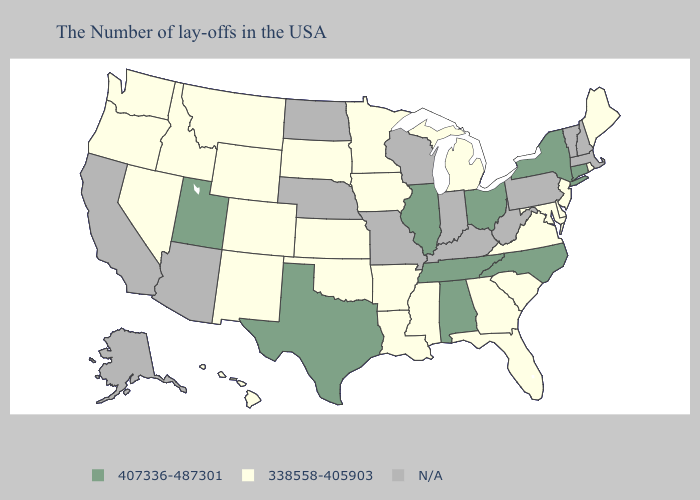What is the lowest value in the USA?
Be succinct. 338558-405903. Name the states that have a value in the range 407336-487301?
Keep it brief. Connecticut, New York, North Carolina, Ohio, Alabama, Tennessee, Illinois, Texas, Utah. Name the states that have a value in the range N/A?
Write a very short answer. Massachusetts, New Hampshire, Vermont, Pennsylvania, West Virginia, Kentucky, Indiana, Wisconsin, Missouri, Nebraska, North Dakota, Arizona, California, Alaska. Which states have the highest value in the USA?
Answer briefly. Connecticut, New York, North Carolina, Ohio, Alabama, Tennessee, Illinois, Texas, Utah. Does Georgia have the lowest value in the USA?
Write a very short answer. Yes. Name the states that have a value in the range 407336-487301?
Concise answer only. Connecticut, New York, North Carolina, Ohio, Alabama, Tennessee, Illinois, Texas, Utah. Which states have the lowest value in the USA?
Write a very short answer. Maine, Rhode Island, New Jersey, Delaware, Maryland, Virginia, South Carolina, Florida, Georgia, Michigan, Mississippi, Louisiana, Arkansas, Minnesota, Iowa, Kansas, Oklahoma, South Dakota, Wyoming, Colorado, New Mexico, Montana, Idaho, Nevada, Washington, Oregon, Hawaii. Name the states that have a value in the range 407336-487301?
Be succinct. Connecticut, New York, North Carolina, Ohio, Alabama, Tennessee, Illinois, Texas, Utah. Which states have the lowest value in the USA?
Write a very short answer. Maine, Rhode Island, New Jersey, Delaware, Maryland, Virginia, South Carolina, Florida, Georgia, Michigan, Mississippi, Louisiana, Arkansas, Minnesota, Iowa, Kansas, Oklahoma, South Dakota, Wyoming, Colorado, New Mexico, Montana, Idaho, Nevada, Washington, Oregon, Hawaii. Which states have the lowest value in the USA?
Give a very brief answer. Maine, Rhode Island, New Jersey, Delaware, Maryland, Virginia, South Carolina, Florida, Georgia, Michigan, Mississippi, Louisiana, Arkansas, Minnesota, Iowa, Kansas, Oklahoma, South Dakota, Wyoming, Colorado, New Mexico, Montana, Idaho, Nevada, Washington, Oregon, Hawaii. Among the states that border New Mexico , does Colorado have the lowest value?
Write a very short answer. Yes. Name the states that have a value in the range 338558-405903?
Concise answer only. Maine, Rhode Island, New Jersey, Delaware, Maryland, Virginia, South Carolina, Florida, Georgia, Michigan, Mississippi, Louisiana, Arkansas, Minnesota, Iowa, Kansas, Oklahoma, South Dakota, Wyoming, Colorado, New Mexico, Montana, Idaho, Nevada, Washington, Oregon, Hawaii. 